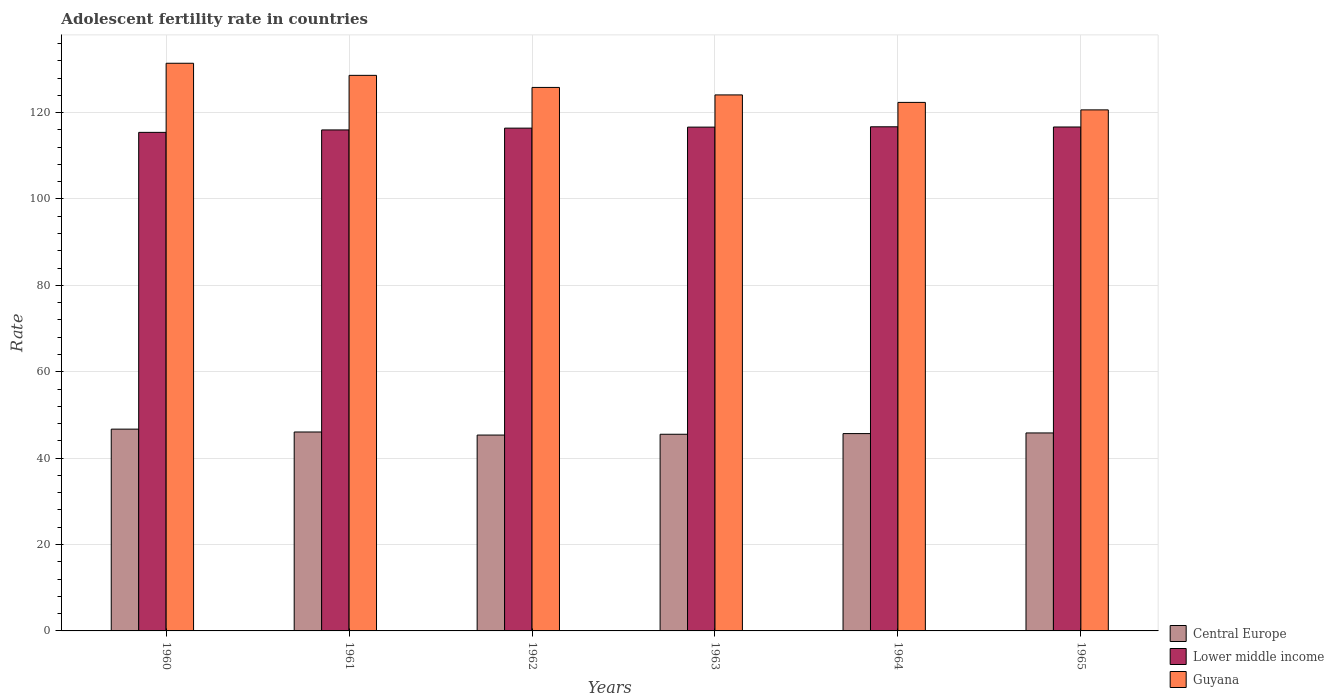Are the number of bars per tick equal to the number of legend labels?
Ensure brevity in your answer.  Yes. Are the number of bars on each tick of the X-axis equal?
Your response must be concise. Yes. How many bars are there on the 3rd tick from the right?
Your answer should be compact. 3. What is the adolescent fertility rate in Lower middle income in 1965?
Give a very brief answer. 116.67. Across all years, what is the maximum adolescent fertility rate in Lower middle income?
Give a very brief answer. 116.71. Across all years, what is the minimum adolescent fertility rate in Central Europe?
Make the answer very short. 45.35. What is the total adolescent fertility rate in Lower middle income in the graph?
Offer a terse response. 697.81. What is the difference between the adolescent fertility rate in Lower middle income in 1960 and that in 1963?
Keep it short and to the point. -1.22. What is the difference between the adolescent fertility rate in Guyana in 1965 and the adolescent fertility rate in Lower middle income in 1964?
Your response must be concise. 3.92. What is the average adolescent fertility rate in Lower middle income per year?
Give a very brief answer. 116.3. In the year 1963, what is the difference between the adolescent fertility rate in Lower middle income and adolescent fertility rate in Guyana?
Make the answer very short. -7.46. In how many years, is the adolescent fertility rate in Guyana greater than 108?
Provide a short and direct response. 6. What is the ratio of the adolescent fertility rate in Guyana in 1963 to that in 1965?
Give a very brief answer. 1.03. What is the difference between the highest and the second highest adolescent fertility rate in Lower middle income?
Your answer should be compact. 0.04. What is the difference between the highest and the lowest adolescent fertility rate in Guyana?
Your answer should be compact. 10.79. In how many years, is the adolescent fertility rate in Central Europe greater than the average adolescent fertility rate in Central Europe taken over all years?
Offer a very short reply. 2. What does the 3rd bar from the left in 1963 represents?
Offer a terse response. Guyana. What does the 3rd bar from the right in 1964 represents?
Your response must be concise. Central Europe. Is it the case that in every year, the sum of the adolescent fertility rate in Central Europe and adolescent fertility rate in Lower middle income is greater than the adolescent fertility rate in Guyana?
Make the answer very short. Yes. How many bars are there?
Provide a short and direct response. 18. Are all the bars in the graph horizontal?
Keep it short and to the point. No. How many years are there in the graph?
Your answer should be compact. 6. Are the values on the major ticks of Y-axis written in scientific E-notation?
Your response must be concise. No. Where does the legend appear in the graph?
Your answer should be compact. Bottom right. How are the legend labels stacked?
Give a very brief answer. Vertical. What is the title of the graph?
Your answer should be compact. Adolescent fertility rate in countries. What is the label or title of the Y-axis?
Offer a very short reply. Rate. What is the Rate of Central Europe in 1960?
Provide a short and direct response. 46.72. What is the Rate in Lower middle income in 1960?
Your response must be concise. 115.42. What is the Rate in Guyana in 1960?
Make the answer very short. 131.42. What is the Rate in Central Europe in 1961?
Your answer should be compact. 46.05. What is the Rate in Lower middle income in 1961?
Ensure brevity in your answer.  115.98. What is the Rate in Guyana in 1961?
Provide a succinct answer. 128.62. What is the Rate of Central Europe in 1962?
Ensure brevity in your answer.  45.35. What is the Rate of Lower middle income in 1962?
Provide a short and direct response. 116.4. What is the Rate in Guyana in 1962?
Your answer should be very brief. 125.82. What is the Rate in Central Europe in 1963?
Keep it short and to the point. 45.53. What is the Rate in Lower middle income in 1963?
Provide a short and direct response. 116.63. What is the Rate in Guyana in 1963?
Make the answer very short. 124.09. What is the Rate of Central Europe in 1964?
Offer a terse response. 45.68. What is the Rate of Lower middle income in 1964?
Your response must be concise. 116.71. What is the Rate in Guyana in 1964?
Your answer should be very brief. 122.36. What is the Rate in Central Europe in 1965?
Your response must be concise. 45.83. What is the Rate of Lower middle income in 1965?
Keep it short and to the point. 116.67. What is the Rate in Guyana in 1965?
Ensure brevity in your answer.  120.63. Across all years, what is the maximum Rate in Central Europe?
Give a very brief answer. 46.72. Across all years, what is the maximum Rate in Lower middle income?
Give a very brief answer. 116.71. Across all years, what is the maximum Rate in Guyana?
Offer a terse response. 131.42. Across all years, what is the minimum Rate of Central Europe?
Make the answer very short. 45.35. Across all years, what is the minimum Rate in Lower middle income?
Provide a succinct answer. 115.42. Across all years, what is the minimum Rate of Guyana?
Your response must be concise. 120.63. What is the total Rate in Central Europe in the graph?
Your response must be concise. 275.17. What is the total Rate of Lower middle income in the graph?
Your answer should be compact. 697.81. What is the total Rate of Guyana in the graph?
Your answer should be very brief. 752.94. What is the difference between the Rate in Central Europe in 1960 and that in 1961?
Give a very brief answer. 0.66. What is the difference between the Rate in Lower middle income in 1960 and that in 1961?
Keep it short and to the point. -0.57. What is the difference between the Rate of Guyana in 1960 and that in 1961?
Your answer should be very brief. 2.8. What is the difference between the Rate of Central Europe in 1960 and that in 1962?
Offer a very short reply. 1.37. What is the difference between the Rate in Lower middle income in 1960 and that in 1962?
Offer a very short reply. -0.98. What is the difference between the Rate in Guyana in 1960 and that in 1962?
Provide a short and direct response. 5.6. What is the difference between the Rate in Central Europe in 1960 and that in 1963?
Your answer should be compact. 1.19. What is the difference between the Rate of Lower middle income in 1960 and that in 1963?
Your answer should be compact. -1.22. What is the difference between the Rate in Guyana in 1960 and that in 1963?
Make the answer very short. 7.33. What is the difference between the Rate of Central Europe in 1960 and that in 1964?
Make the answer very short. 1.03. What is the difference between the Rate of Lower middle income in 1960 and that in 1964?
Make the answer very short. -1.29. What is the difference between the Rate in Guyana in 1960 and that in 1964?
Your response must be concise. 9.06. What is the difference between the Rate of Central Europe in 1960 and that in 1965?
Provide a succinct answer. 0.88. What is the difference between the Rate in Lower middle income in 1960 and that in 1965?
Provide a short and direct response. -1.25. What is the difference between the Rate in Guyana in 1960 and that in 1965?
Provide a short and direct response. 10.79. What is the difference between the Rate of Central Europe in 1961 and that in 1962?
Your answer should be compact. 0.71. What is the difference between the Rate of Lower middle income in 1961 and that in 1962?
Give a very brief answer. -0.42. What is the difference between the Rate in Guyana in 1961 and that in 1962?
Your answer should be compact. 2.8. What is the difference between the Rate of Central Europe in 1961 and that in 1963?
Offer a terse response. 0.52. What is the difference between the Rate of Lower middle income in 1961 and that in 1963?
Offer a very short reply. -0.65. What is the difference between the Rate in Guyana in 1961 and that in 1963?
Keep it short and to the point. 4.53. What is the difference between the Rate in Central Europe in 1961 and that in 1964?
Ensure brevity in your answer.  0.37. What is the difference between the Rate in Lower middle income in 1961 and that in 1964?
Offer a terse response. -0.73. What is the difference between the Rate of Guyana in 1961 and that in 1964?
Ensure brevity in your answer.  6.26. What is the difference between the Rate of Central Europe in 1961 and that in 1965?
Give a very brief answer. 0.22. What is the difference between the Rate of Lower middle income in 1961 and that in 1965?
Your response must be concise. -0.68. What is the difference between the Rate of Guyana in 1961 and that in 1965?
Make the answer very short. 7.99. What is the difference between the Rate of Central Europe in 1962 and that in 1963?
Ensure brevity in your answer.  -0.18. What is the difference between the Rate in Lower middle income in 1962 and that in 1963?
Ensure brevity in your answer.  -0.23. What is the difference between the Rate in Guyana in 1962 and that in 1963?
Your answer should be compact. 1.73. What is the difference between the Rate in Central Europe in 1962 and that in 1964?
Keep it short and to the point. -0.34. What is the difference between the Rate in Lower middle income in 1962 and that in 1964?
Make the answer very short. -0.31. What is the difference between the Rate of Guyana in 1962 and that in 1964?
Your response must be concise. 3.46. What is the difference between the Rate of Central Europe in 1962 and that in 1965?
Your answer should be compact. -0.49. What is the difference between the Rate in Lower middle income in 1962 and that in 1965?
Make the answer very short. -0.27. What is the difference between the Rate in Guyana in 1962 and that in 1965?
Provide a short and direct response. 5.2. What is the difference between the Rate in Central Europe in 1963 and that in 1964?
Give a very brief answer. -0.15. What is the difference between the Rate in Lower middle income in 1963 and that in 1964?
Give a very brief answer. -0.07. What is the difference between the Rate of Guyana in 1963 and that in 1964?
Your response must be concise. 1.73. What is the difference between the Rate in Central Europe in 1963 and that in 1965?
Keep it short and to the point. -0.3. What is the difference between the Rate of Lower middle income in 1963 and that in 1965?
Provide a short and direct response. -0.03. What is the difference between the Rate in Guyana in 1963 and that in 1965?
Your answer should be compact. 3.46. What is the difference between the Rate in Lower middle income in 1964 and that in 1965?
Your response must be concise. 0.04. What is the difference between the Rate of Guyana in 1964 and that in 1965?
Give a very brief answer. 1.73. What is the difference between the Rate in Central Europe in 1960 and the Rate in Lower middle income in 1961?
Provide a short and direct response. -69.27. What is the difference between the Rate in Central Europe in 1960 and the Rate in Guyana in 1961?
Give a very brief answer. -81.9. What is the difference between the Rate of Lower middle income in 1960 and the Rate of Guyana in 1961?
Give a very brief answer. -13.2. What is the difference between the Rate in Central Europe in 1960 and the Rate in Lower middle income in 1962?
Your response must be concise. -69.68. What is the difference between the Rate in Central Europe in 1960 and the Rate in Guyana in 1962?
Your response must be concise. -79.11. What is the difference between the Rate in Lower middle income in 1960 and the Rate in Guyana in 1962?
Provide a short and direct response. -10.41. What is the difference between the Rate of Central Europe in 1960 and the Rate of Lower middle income in 1963?
Make the answer very short. -69.92. What is the difference between the Rate of Central Europe in 1960 and the Rate of Guyana in 1963?
Offer a very short reply. -77.37. What is the difference between the Rate of Lower middle income in 1960 and the Rate of Guyana in 1963?
Your answer should be very brief. -8.67. What is the difference between the Rate of Central Europe in 1960 and the Rate of Lower middle income in 1964?
Offer a very short reply. -69.99. What is the difference between the Rate in Central Europe in 1960 and the Rate in Guyana in 1964?
Your response must be concise. -75.64. What is the difference between the Rate in Lower middle income in 1960 and the Rate in Guyana in 1964?
Ensure brevity in your answer.  -6.94. What is the difference between the Rate in Central Europe in 1960 and the Rate in Lower middle income in 1965?
Ensure brevity in your answer.  -69.95. What is the difference between the Rate of Central Europe in 1960 and the Rate of Guyana in 1965?
Keep it short and to the point. -73.91. What is the difference between the Rate in Lower middle income in 1960 and the Rate in Guyana in 1965?
Your response must be concise. -5.21. What is the difference between the Rate of Central Europe in 1961 and the Rate of Lower middle income in 1962?
Your response must be concise. -70.35. What is the difference between the Rate of Central Europe in 1961 and the Rate of Guyana in 1962?
Provide a succinct answer. -79.77. What is the difference between the Rate of Lower middle income in 1961 and the Rate of Guyana in 1962?
Your response must be concise. -9.84. What is the difference between the Rate in Central Europe in 1961 and the Rate in Lower middle income in 1963?
Your answer should be compact. -70.58. What is the difference between the Rate in Central Europe in 1961 and the Rate in Guyana in 1963?
Ensure brevity in your answer.  -78.04. What is the difference between the Rate of Lower middle income in 1961 and the Rate of Guyana in 1963?
Ensure brevity in your answer.  -8.11. What is the difference between the Rate of Central Europe in 1961 and the Rate of Lower middle income in 1964?
Offer a terse response. -70.66. What is the difference between the Rate of Central Europe in 1961 and the Rate of Guyana in 1964?
Ensure brevity in your answer.  -76.3. What is the difference between the Rate of Lower middle income in 1961 and the Rate of Guyana in 1964?
Your answer should be very brief. -6.38. What is the difference between the Rate of Central Europe in 1961 and the Rate of Lower middle income in 1965?
Give a very brief answer. -70.61. What is the difference between the Rate in Central Europe in 1961 and the Rate in Guyana in 1965?
Give a very brief answer. -74.57. What is the difference between the Rate in Lower middle income in 1961 and the Rate in Guyana in 1965?
Ensure brevity in your answer.  -4.64. What is the difference between the Rate of Central Europe in 1962 and the Rate of Lower middle income in 1963?
Provide a succinct answer. -71.29. What is the difference between the Rate in Central Europe in 1962 and the Rate in Guyana in 1963?
Provide a succinct answer. -78.75. What is the difference between the Rate in Lower middle income in 1962 and the Rate in Guyana in 1963?
Provide a short and direct response. -7.69. What is the difference between the Rate of Central Europe in 1962 and the Rate of Lower middle income in 1964?
Offer a very short reply. -71.36. What is the difference between the Rate in Central Europe in 1962 and the Rate in Guyana in 1964?
Provide a short and direct response. -77.01. What is the difference between the Rate of Lower middle income in 1962 and the Rate of Guyana in 1964?
Ensure brevity in your answer.  -5.96. What is the difference between the Rate of Central Europe in 1962 and the Rate of Lower middle income in 1965?
Keep it short and to the point. -71.32. What is the difference between the Rate of Central Europe in 1962 and the Rate of Guyana in 1965?
Ensure brevity in your answer.  -75.28. What is the difference between the Rate of Lower middle income in 1962 and the Rate of Guyana in 1965?
Your answer should be very brief. -4.23. What is the difference between the Rate of Central Europe in 1963 and the Rate of Lower middle income in 1964?
Give a very brief answer. -71.18. What is the difference between the Rate of Central Europe in 1963 and the Rate of Guyana in 1964?
Your answer should be compact. -76.83. What is the difference between the Rate in Lower middle income in 1963 and the Rate in Guyana in 1964?
Offer a very short reply. -5.72. What is the difference between the Rate in Central Europe in 1963 and the Rate in Lower middle income in 1965?
Your answer should be very brief. -71.14. What is the difference between the Rate of Central Europe in 1963 and the Rate of Guyana in 1965?
Make the answer very short. -75.1. What is the difference between the Rate in Lower middle income in 1963 and the Rate in Guyana in 1965?
Keep it short and to the point. -3.99. What is the difference between the Rate in Central Europe in 1964 and the Rate in Lower middle income in 1965?
Ensure brevity in your answer.  -70.98. What is the difference between the Rate in Central Europe in 1964 and the Rate in Guyana in 1965?
Your answer should be very brief. -74.94. What is the difference between the Rate of Lower middle income in 1964 and the Rate of Guyana in 1965?
Give a very brief answer. -3.92. What is the average Rate in Central Europe per year?
Your answer should be very brief. 45.86. What is the average Rate of Lower middle income per year?
Your answer should be very brief. 116.3. What is the average Rate in Guyana per year?
Your answer should be very brief. 125.49. In the year 1960, what is the difference between the Rate of Central Europe and Rate of Lower middle income?
Offer a terse response. -68.7. In the year 1960, what is the difference between the Rate of Central Europe and Rate of Guyana?
Offer a very short reply. -84.7. In the year 1960, what is the difference between the Rate of Lower middle income and Rate of Guyana?
Ensure brevity in your answer.  -16. In the year 1961, what is the difference between the Rate in Central Europe and Rate in Lower middle income?
Ensure brevity in your answer.  -69.93. In the year 1961, what is the difference between the Rate of Central Europe and Rate of Guyana?
Provide a succinct answer. -82.57. In the year 1961, what is the difference between the Rate in Lower middle income and Rate in Guyana?
Your response must be concise. -12.64. In the year 1962, what is the difference between the Rate in Central Europe and Rate in Lower middle income?
Give a very brief answer. -71.05. In the year 1962, what is the difference between the Rate in Central Europe and Rate in Guyana?
Your answer should be very brief. -80.48. In the year 1962, what is the difference between the Rate of Lower middle income and Rate of Guyana?
Make the answer very short. -9.42. In the year 1963, what is the difference between the Rate in Central Europe and Rate in Lower middle income?
Your answer should be compact. -71.11. In the year 1963, what is the difference between the Rate in Central Europe and Rate in Guyana?
Provide a succinct answer. -78.56. In the year 1963, what is the difference between the Rate in Lower middle income and Rate in Guyana?
Make the answer very short. -7.46. In the year 1964, what is the difference between the Rate in Central Europe and Rate in Lower middle income?
Provide a short and direct response. -71.03. In the year 1964, what is the difference between the Rate of Central Europe and Rate of Guyana?
Offer a very short reply. -76.67. In the year 1964, what is the difference between the Rate in Lower middle income and Rate in Guyana?
Make the answer very short. -5.65. In the year 1965, what is the difference between the Rate in Central Europe and Rate in Lower middle income?
Provide a short and direct response. -70.83. In the year 1965, what is the difference between the Rate of Central Europe and Rate of Guyana?
Your answer should be very brief. -74.79. In the year 1965, what is the difference between the Rate in Lower middle income and Rate in Guyana?
Offer a terse response. -3.96. What is the ratio of the Rate in Central Europe in 1960 to that in 1961?
Keep it short and to the point. 1.01. What is the ratio of the Rate in Lower middle income in 1960 to that in 1961?
Ensure brevity in your answer.  1. What is the ratio of the Rate in Guyana in 1960 to that in 1961?
Provide a short and direct response. 1.02. What is the ratio of the Rate in Central Europe in 1960 to that in 1962?
Keep it short and to the point. 1.03. What is the ratio of the Rate in Lower middle income in 1960 to that in 1962?
Offer a very short reply. 0.99. What is the ratio of the Rate of Guyana in 1960 to that in 1962?
Your answer should be very brief. 1.04. What is the ratio of the Rate in Central Europe in 1960 to that in 1963?
Give a very brief answer. 1.03. What is the ratio of the Rate of Guyana in 1960 to that in 1963?
Ensure brevity in your answer.  1.06. What is the ratio of the Rate of Central Europe in 1960 to that in 1964?
Your answer should be compact. 1.02. What is the ratio of the Rate of Lower middle income in 1960 to that in 1964?
Make the answer very short. 0.99. What is the ratio of the Rate of Guyana in 1960 to that in 1964?
Offer a very short reply. 1.07. What is the ratio of the Rate in Central Europe in 1960 to that in 1965?
Give a very brief answer. 1.02. What is the ratio of the Rate of Lower middle income in 1960 to that in 1965?
Offer a terse response. 0.99. What is the ratio of the Rate in Guyana in 1960 to that in 1965?
Your answer should be very brief. 1.09. What is the ratio of the Rate in Central Europe in 1961 to that in 1962?
Your answer should be very brief. 1.02. What is the ratio of the Rate in Lower middle income in 1961 to that in 1962?
Provide a short and direct response. 1. What is the ratio of the Rate of Guyana in 1961 to that in 1962?
Keep it short and to the point. 1.02. What is the ratio of the Rate of Central Europe in 1961 to that in 1963?
Your answer should be very brief. 1.01. What is the ratio of the Rate in Guyana in 1961 to that in 1963?
Give a very brief answer. 1.04. What is the ratio of the Rate of Central Europe in 1961 to that in 1964?
Ensure brevity in your answer.  1.01. What is the ratio of the Rate of Lower middle income in 1961 to that in 1964?
Give a very brief answer. 0.99. What is the ratio of the Rate of Guyana in 1961 to that in 1964?
Your answer should be compact. 1.05. What is the ratio of the Rate in Lower middle income in 1961 to that in 1965?
Provide a short and direct response. 0.99. What is the ratio of the Rate in Guyana in 1961 to that in 1965?
Offer a very short reply. 1.07. What is the ratio of the Rate of Lower middle income in 1962 to that in 1963?
Make the answer very short. 1. What is the ratio of the Rate in Guyana in 1962 to that in 1964?
Your answer should be very brief. 1.03. What is the ratio of the Rate of Central Europe in 1962 to that in 1965?
Your answer should be very brief. 0.99. What is the ratio of the Rate of Guyana in 1962 to that in 1965?
Provide a succinct answer. 1.04. What is the ratio of the Rate in Central Europe in 1963 to that in 1964?
Offer a very short reply. 1. What is the ratio of the Rate in Lower middle income in 1963 to that in 1964?
Provide a succinct answer. 1. What is the ratio of the Rate of Guyana in 1963 to that in 1964?
Give a very brief answer. 1.01. What is the ratio of the Rate in Central Europe in 1963 to that in 1965?
Keep it short and to the point. 0.99. What is the ratio of the Rate of Guyana in 1963 to that in 1965?
Your response must be concise. 1.03. What is the ratio of the Rate in Lower middle income in 1964 to that in 1965?
Your answer should be very brief. 1. What is the ratio of the Rate in Guyana in 1964 to that in 1965?
Ensure brevity in your answer.  1.01. What is the difference between the highest and the second highest Rate in Central Europe?
Your response must be concise. 0.66. What is the difference between the highest and the second highest Rate of Lower middle income?
Provide a succinct answer. 0.04. What is the difference between the highest and the second highest Rate of Guyana?
Ensure brevity in your answer.  2.8. What is the difference between the highest and the lowest Rate in Central Europe?
Keep it short and to the point. 1.37. What is the difference between the highest and the lowest Rate of Lower middle income?
Your answer should be compact. 1.29. What is the difference between the highest and the lowest Rate of Guyana?
Offer a very short reply. 10.79. 